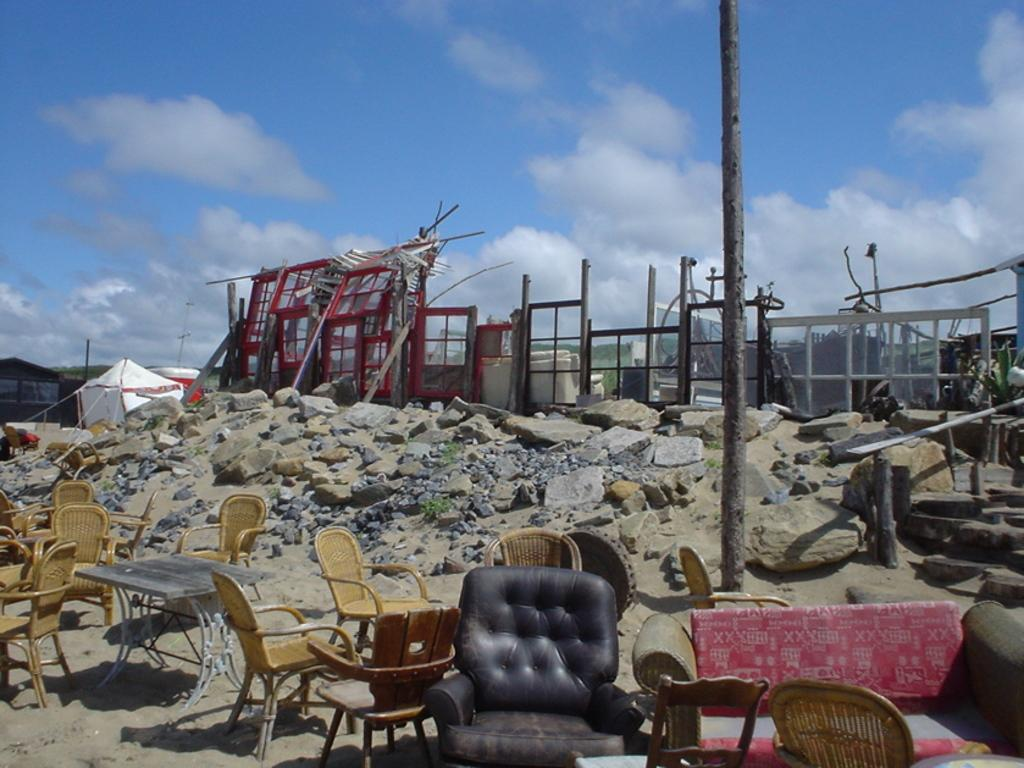Where is the setting of the image? The image appears to be outside of the city. What furniture can be seen in the background? There are chairs and a table in the background. What type of terrain is visible in the background? There are stones in the background. What structures are visible in the background? There are buildings and tents in the background. What is visible at the top of the image? The sky is visible at the top of the image. How many geese are flying in the sky in the image? There are no geese visible in the sky in the image. What type of parent is present in the image? There is no parent present in the image. 